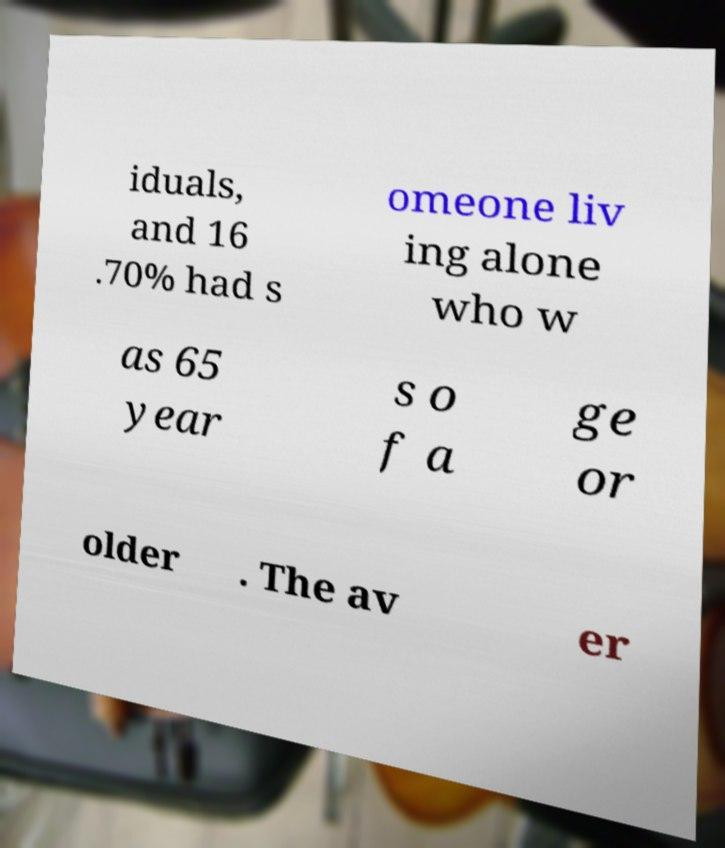Could you extract and type out the text from this image? iduals, and 16 .70% had s omeone liv ing alone who w as 65 year s o f a ge or older . The av er 